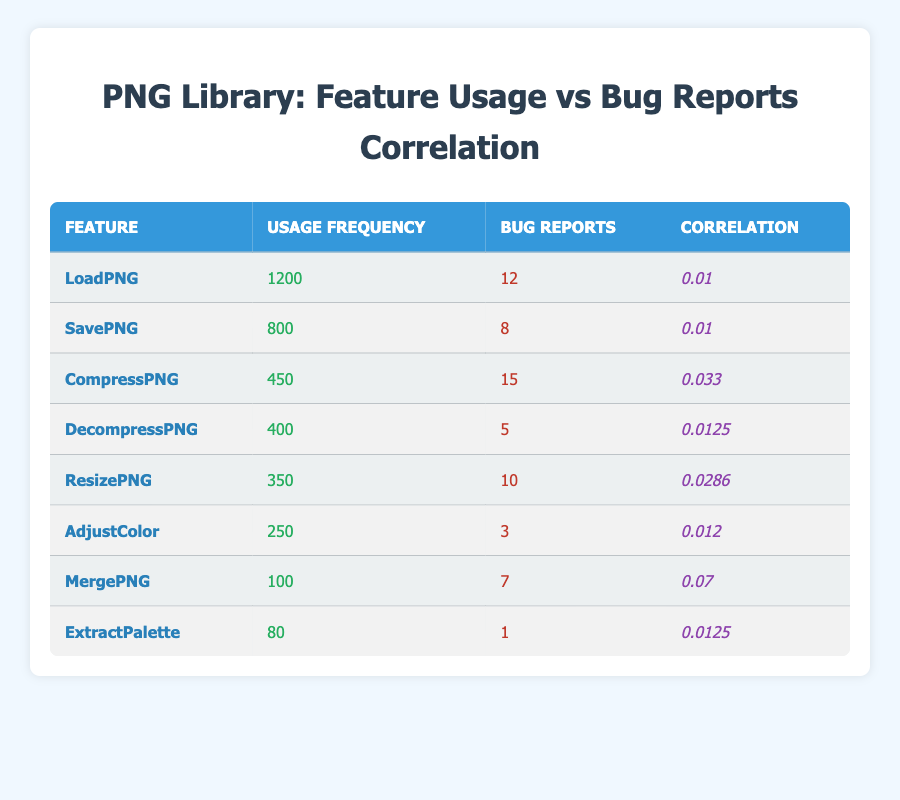What is the usage frequency of LoadPNG? The usage frequency is listed directly in the table under the "Usage Frequency" column for the feature "LoadPNG". The value is 1200.
Answer: 1200 How many bug reports were filed for SavePNG? The table specifies the number of bug reports under the "Bug Reports" column for "SavePNG". The value is 8.
Answer: 8 Which feature has the highest correlation with bug reports? To find the feature with the highest correlation, we can compare all values in the "Correlation" column. "MergePNG" has the highest correlation value of 0.07.
Answer: MergePNG What is the average number of bug reports across all features? First, we sum the bug report counts for all features: 12 + 8 + 15 + 5 + 10 + 3 + 7 + 1 = 61. There are 8 features, so the average is 61/8 = 7.625.
Answer: 7.625 Is the correlation for DecompressPNG higher than that for AdjustColor? By comparing the correlation values in the table, DecompressPNG has a correlation of 0.0125 and AdjustColor has a correlation of 0.012. Since 0.0125 is greater than 0.012, the statement is true.
Answer: Yes If the usage frequency for ExtractPalette were to double, what would its new usage frequency be? The "Usage Frequency" for ExtractPalette is currently 80. If it doubles, it will be 80 * 2 = 160.
Answer: 160 Are there more bug reports for CompressPNG than for MergePNG? The table indicates that CompressPNG has 15 bug reports and MergePNG has 7. Since 15 is greater than 7, the answer is yes.
Answer: Yes What is the total usage frequency for all features combined? We sum the usage frequencies of all features: 1200 + 800 + 450 + 400 + 350 + 250 + 100 + 80 = 3530.
Answer: 3530 How does the bug report frequency for the least used feature (ExtractPalette) compare to the most used feature (LoadPNG)? ExtractPalette has 1 bug report while LoadPNG has 12. Since 1 is significantly less than 12, we can conclude that the bug report frequency for ExtractPalette is much lower.
Answer: Much lower 